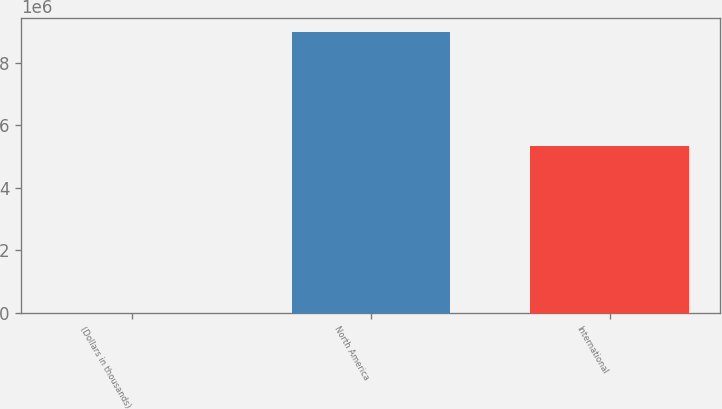Convert chart to OTSL. <chart><loc_0><loc_0><loc_500><loc_500><bar_chart><fcel>(Dollars in thousands)<fcel>North America<fcel>International<nl><fcel>2018<fcel>8.97849e+06<fcel>5.3239e+06<nl></chart> 